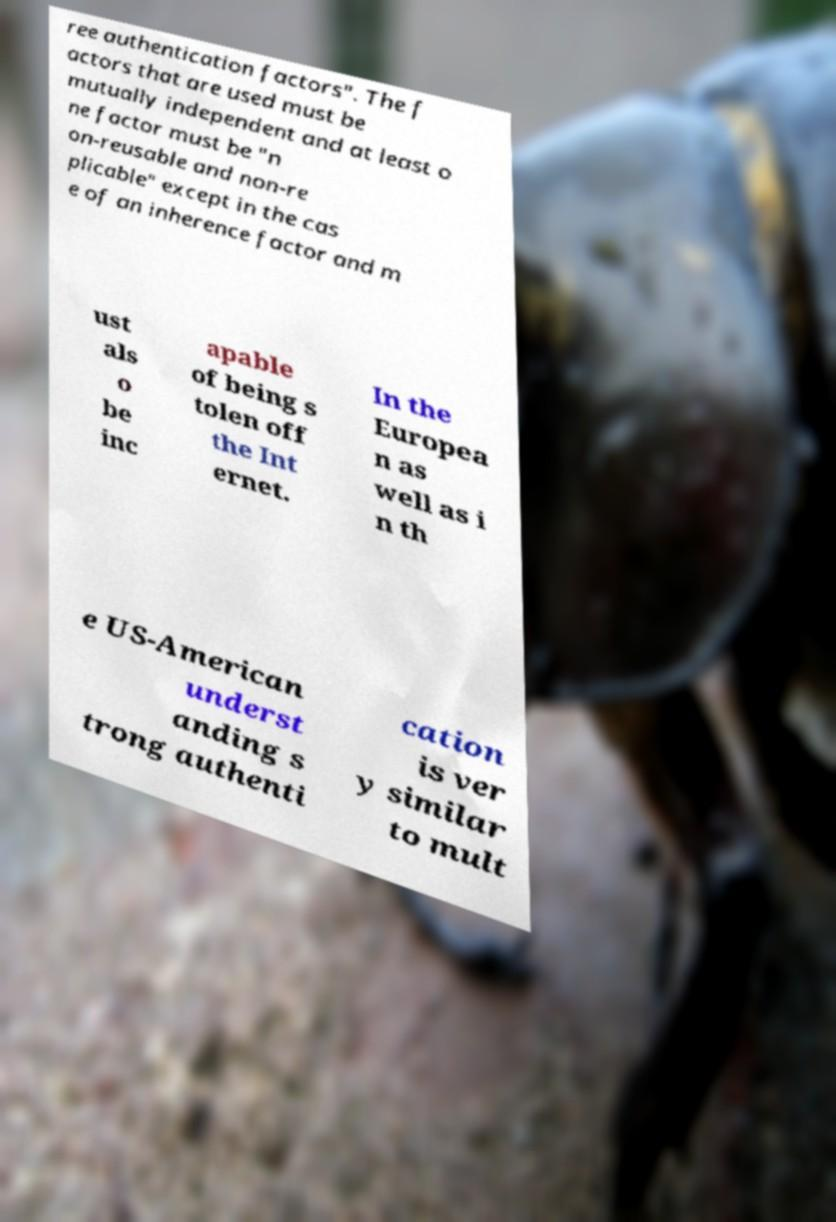What messages or text are displayed in this image? I need them in a readable, typed format. ree authentication factors". The f actors that are used must be mutually independent and at least o ne factor must be "n on-reusable and non-re plicable" except in the cas e of an inherence factor and m ust als o be inc apable of being s tolen off the Int ernet. In the Europea n as well as i n th e US-American underst anding s trong authenti cation is ver y similar to mult 